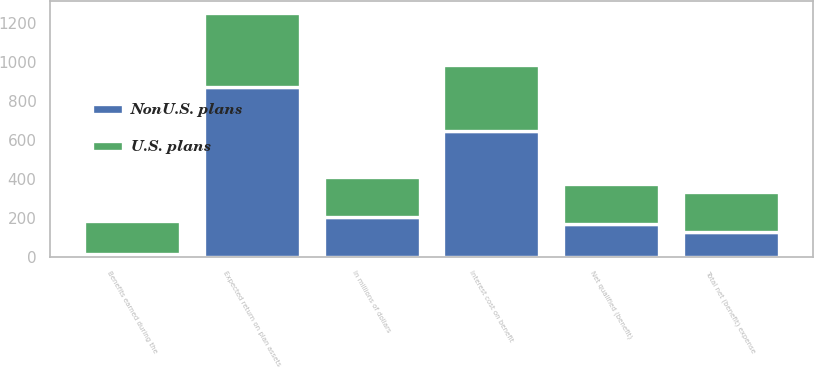Convert chart. <chart><loc_0><loc_0><loc_500><loc_500><stacked_bar_chart><ecel><fcel>In millions of dollars<fcel>Benefits earned during the<fcel>Interest cost on benefit<fcel>Expected return on plan assets<fcel>Net qualified (benefit)<fcel>Total net (benefit) expense<nl><fcel>NonU.S. plans<fcel>204<fcel>14<fcel>644<fcel>874<fcel>170<fcel>129<nl><fcel>U.S. plans<fcel>204<fcel>167<fcel>342<fcel>378<fcel>204<fcel>204<nl></chart> 